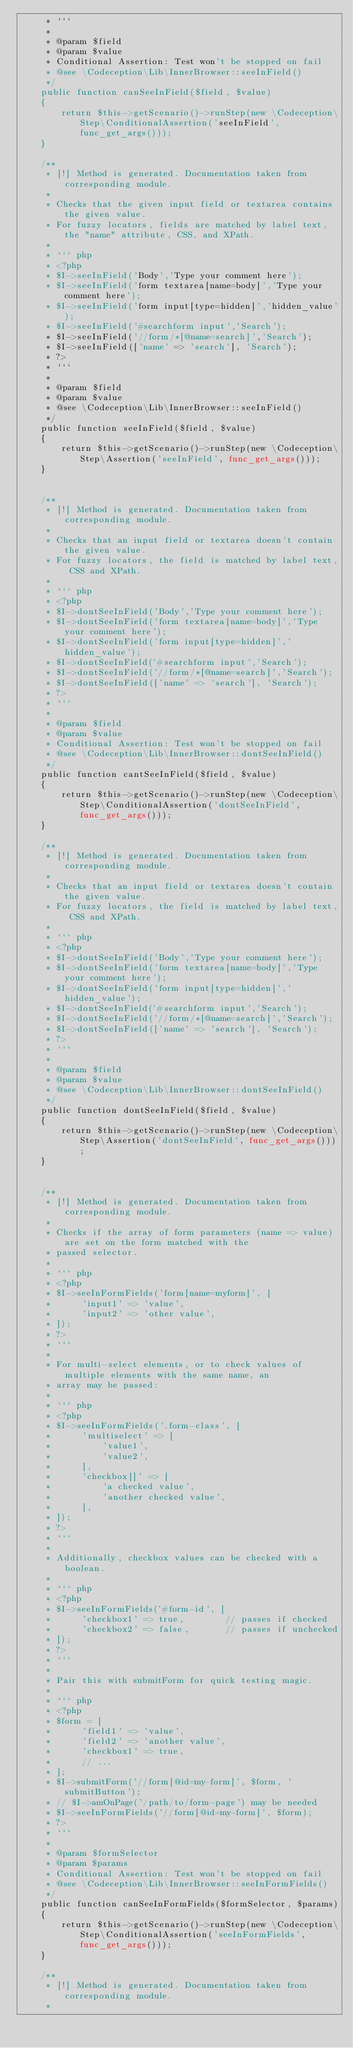Convert code to text. <code><loc_0><loc_0><loc_500><loc_500><_PHP_>     * ```
     *
     * @param $field
     * @param $value
     * Conditional Assertion: Test won't be stopped on fail
     * @see \Codeception\Lib\InnerBrowser::seeInField()
     */
    public function canSeeInField($field, $value)
    {
        return $this->getScenario()->runStep(new \Codeception\Step\ConditionalAssertion('seeInField', func_get_args()));
    }

    /**
     * [!] Method is generated. Documentation taken from corresponding module.
     *
     * Checks that the given input field or textarea contains the given value.
     * For fuzzy locators, fields are matched by label text, the "name" attribute, CSS, and XPath.
     *
     * ``` php
     * <?php
     * $I->seeInField('Body','Type your comment here');
     * $I->seeInField('form textarea[name=body]','Type your comment here');
     * $I->seeInField('form input[type=hidden]','hidden_value');
     * $I->seeInField('#searchform input','Search');
     * $I->seeInField('//form/*[@name=search]','Search');
     * $I->seeInField(['name' => 'search'], 'Search');
     * ?>
     * ```
     *
     * @param $field
     * @param $value
     * @see \Codeception\Lib\InnerBrowser::seeInField()
     */
    public function seeInField($field, $value)
    {
        return $this->getScenario()->runStep(new \Codeception\Step\Assertion('seeInField', func_get_args()));
    }


    /**
     * [!] Method is generated. Documentation taken from corresponding module.
     *
     * Checks that an input field or textarea doesn't contain the given value.
     * For fuzzy locators, the field is matched by label text, CSS and XPath.
     *
     * ``` php
     * <?php
     * $I->dontSeeInField('Body','Type your comment here');
     * $I->dontSeeInField('form textarea[name=body]','Type your comment here');
     * $I->dontSeeInField('form input[type=hidden]','hidden_value');
     * $I->dontSeeInField('#searchform input','Search');
     * $I->dontSeeInField('//form/*[@name=search]','Search');
     * $I->dontSeeInField(['name' => 'search'], 'Search');
     * ?>
     * ```
     *
     * @param $field
     * @param $value
     * Conditional Assertion: Test won't be stopped on fail
     * @see \Codeception\Lib\InnerBrowser::dontSeeInField()
     */
    public function cantSeeInField($field, $value)
    {
        return $this->getScenario()->runStep(new \Codeception\Step\ConditionalAssertion('dontSeeInField', func_get_args()));
    }

    /**
     * [!] Method is generated. Documentation taken from corresponding module.
     *
     * Checks that an input field or textarea doesn't contain the given value.
     * For fuzzy locators, the field is matched by label text, CSS and XPath.
     *
     * ``` php
     * <?php
     * $I->dontSeeInField('Body','Type your comment here');
     * $I->dontSeeInField('form textarea[name=body]','Type your comment here');
     * $I->dontSeeInField('form input[type=hidden]','hidden_value');
     * $I->dontSeeInField('#searchform input','Search');
     * $I->dontSeeInField('//form/*[@name=search]','Search');
     * $I->dontSeeInField(['name' => 'search'], 'Search');
     * ?>
     * ```
     *
     * @param $field
     * @param $value
     * @see \Codeception\Lib\InnerBrowser::dontSeeInField()
     */
    public function dontSeeInField($field, $value)
    {
        return $this->getScenario()->runStep(new \Codeception\Step\Assertion('dontSeeInField', func_get_args()));
    }


    /**
     * [!] Method is generated. Documentation taken from corresponding module.
     *
     * Checks if the array of form parameters (name => value) are set on the form matched with the
     * passed selector.
     *
     * ``` php
     * <?php
     * $I->seeInFormFields('form[name=myform]', [
     *      'input1' => 'value',
     *      'input2' => 'other value',
     * ]);
     * ?>
     * ```
     *
     * For multi-select elements, or to check values of multiple elements with the same name, an
     * array may be passed:
     *
     * ``` php
     * <?php
     * $I->seeInFormFields('.form-class', [
     *      'multiselect' => [
     *          'value1',
     *          'value2',
     *      ],
     *      'checkbox[]' => [
     *          'a checked value',
     *          'another checked value',
     *      ],
     * ]);
     * ?>
     * ```
     *
     * Additionally, checkbox values can be checked with a boolean.
     *
     * ``` php
     * <?php
     * $I->seeInFormFields('#form-id', [
     *      'checkbox1' => true,        // passes if checked
     *      'checkbox2' => false,       // passes if unchecked
     * ]);
     * ?>
     * ```
     *
     * Pair this with submitForm for quick testing magic.
     *
     * ``` php
     * <?php
     * $form = [
     *      'field1' => 'value',
     *      'field2' => 'another value',
     *      'checkbox1' => true,
     *      // ...
     * ];
     * $I->submitForm('//form[@id=my-form]', $form, 'submitButton');
     * // $I->amOnPage('/path/to/form-page') may be needed
     * $I->seeInFormFields('//form[@id=my-form]', $form);
     * ?>
     * ```
     *
     * @param $formSelector
     * @param $params
     * Conditional Assertion: Test won't be stopped on fail
     * @see \Codeception\Lib\InnerBrowser::seeInFormFields()
     */
    public function canSeeInFormFields($formSelector, $params)
    {
        return $this->getScenario()->runStep(new \Codeception\Step\ConditionalAssertion('seeInFormFields', func_get_args()));
    }

    /**
     * [!] Method is generated. Documentation taken from corresponding module.
     *</code> 